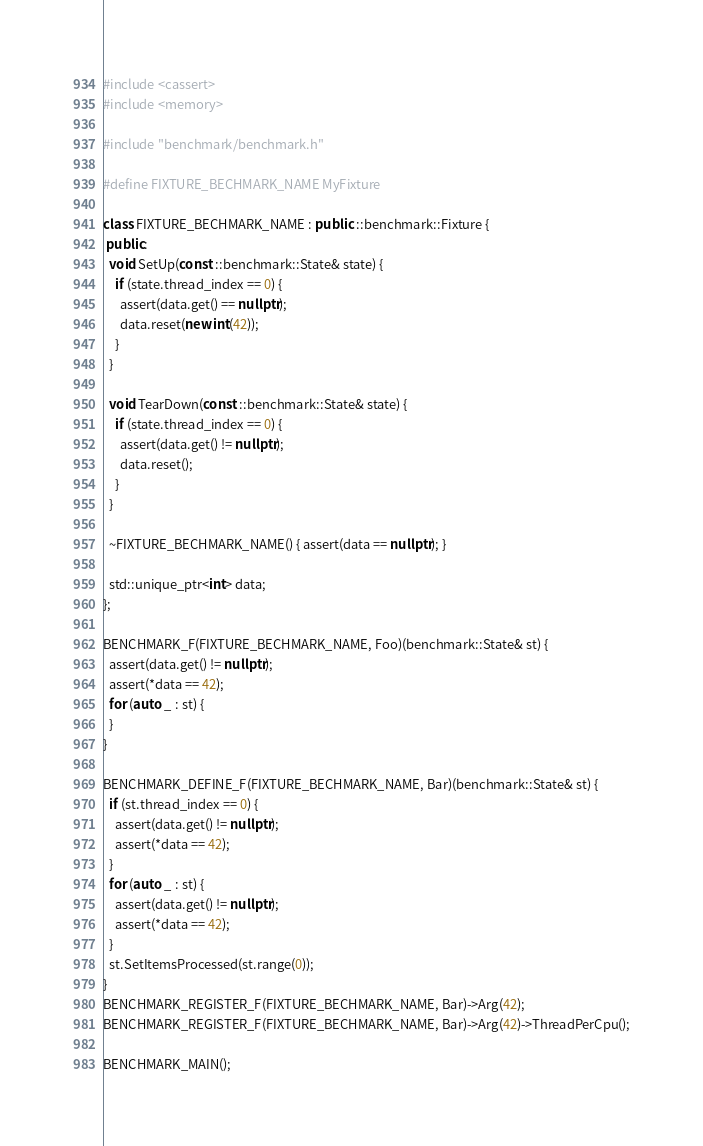Convert code to text. <code><loc_0><loc_0><loc_500><loc_500><_C++_>
#include <cassert>
#include <memory>

#include "benchmark/benchmark.h"

#define FIXTURE_BECHMARK_NAME MyFixture

class FIXTURE_BECHMARK_NAME : public ::benchmark::Fixture {
 public:
  void SetUp(const ::benchmark::State& state) {
    if (state.thread_index == 0) {
      assert(data.get() == nullptr);
      data.reset(new int(42));
    }
  }

  void TearDown(const ::benchmark::State& state) {
    if (state.thread_index == 0) {
      assert(data.get() != nullptr);
      data.reset();
    }
  }

  ~FIXTURE_BECHMARK_NAME() { assert(data == nullptr); }

  std::unique_ptr<int> data;
};

BENCHMARK_F(FIXTURE_BECHMARK_NAME, Foo)(benchmark::State& st) {
  assert(data.get() != nullptr);
  assert(*data == 42);
  for (auto _ : st) {
  }
}

BENCHMARK_DEFINE_F(FIXTURE_BECHMARK_NAME, Bar)(benchmark::State& st) {
  if (st.thread_index == 0) {
    assert(data.get() != nullptr);
    assert(*data == 42);
  }
  for (auto _ : st) {
    assert(data.get() != nullptr);
    assert(*data == 42);
  }
  st.SetItemsProcessed(st.range(0));
}
BENCHMARK_REGISTER_F(FIXTURE_BECHMARK_NAME, Bar)->Arg(42);
BENCHMARK_REGISTER_F(FIXTURE_BECHMARK_NAME, Bar)->Arg(42)->ThreadPerCpu();

BENCHMARK_MAIN();
</code> 